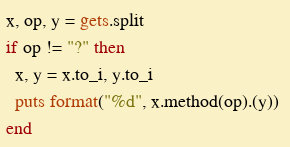<code> <loc_0><loc_0><loc_500><loc_500><_Ruby_>x, op, y = gets.split
if op != "?" then
  x, y = x.to_i, y.to_i
  puts format("%d", x.method(op).(y)) 
end</code> 